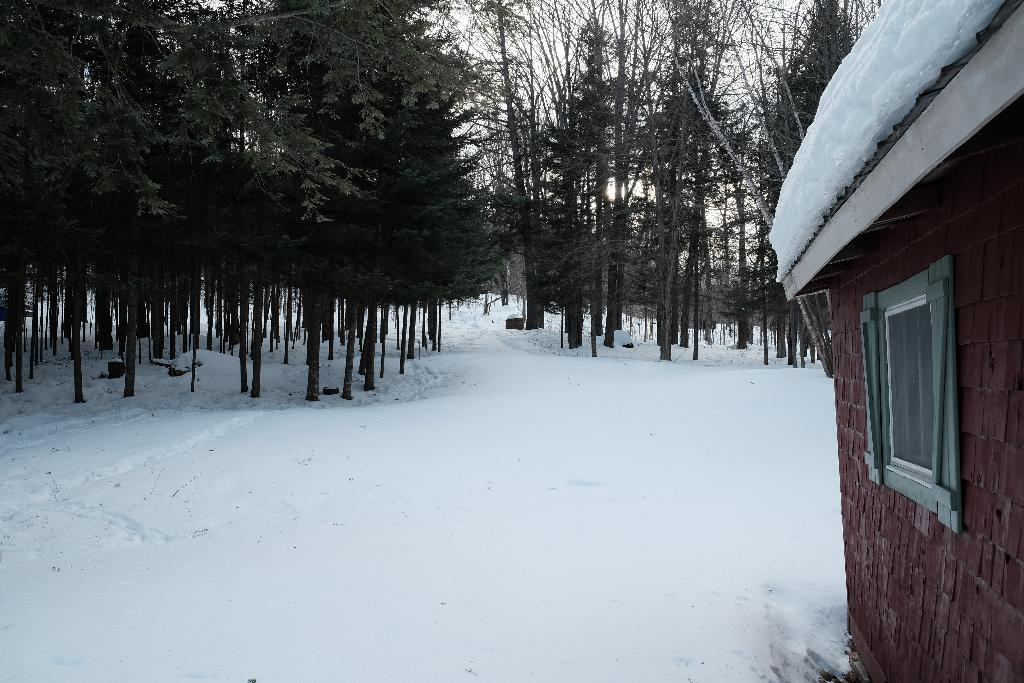What is the predominant weather condition in the image? There is snow in the image, indicating a cold and wintry condition. What type of structure is present in the image? There is a house in the image. Can you describe a specific feature of the house? There is a window in the house. What type of natural environment can be seen in the image? There are trees visible in the image. What is visible in the background of the image? The sky is visible in the image. What type of produce is being harvested in the image? There is no produce visible in the image; it features snow, a house, trees, and the sky. What type of beam is supporting the roof of the house in the image? There is no visible beam supporting the roof of the house in the image. 